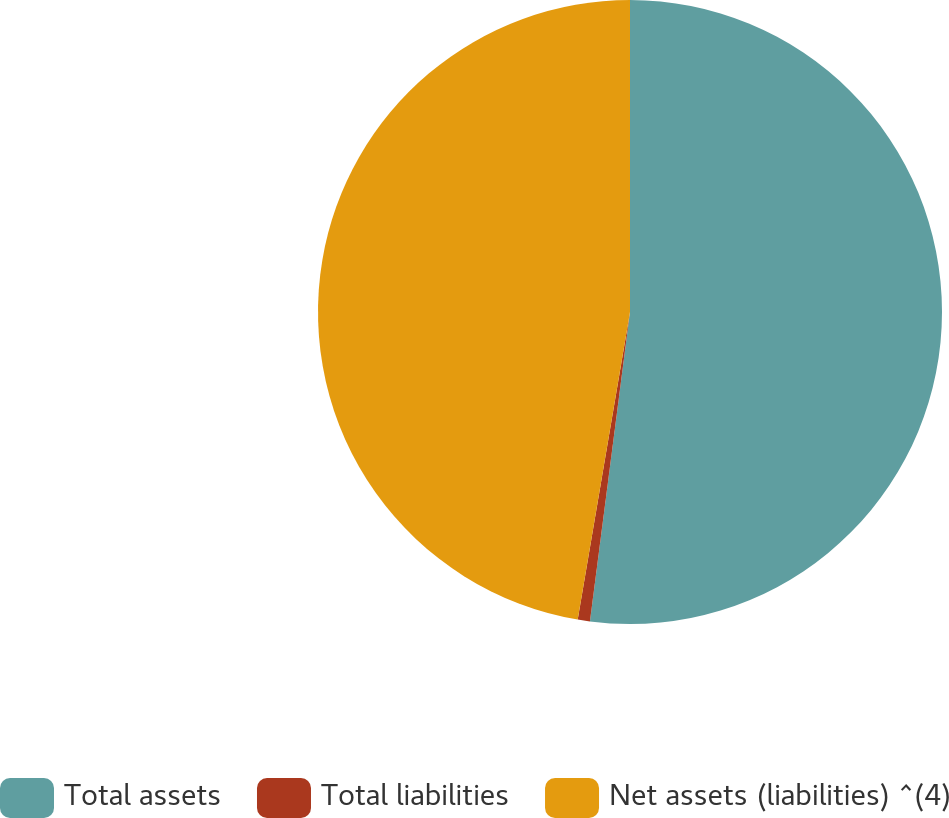<chart> <loc_0><loc_0><loc_500><loc_500><pie_chart><fcel>Total assets<fcel>Total liabilities<fcel>Net assets (liabilities) ^(4)<nl><fcel>52.05%<fcel>0.63%<fcel>47.32%<nl></chart> 